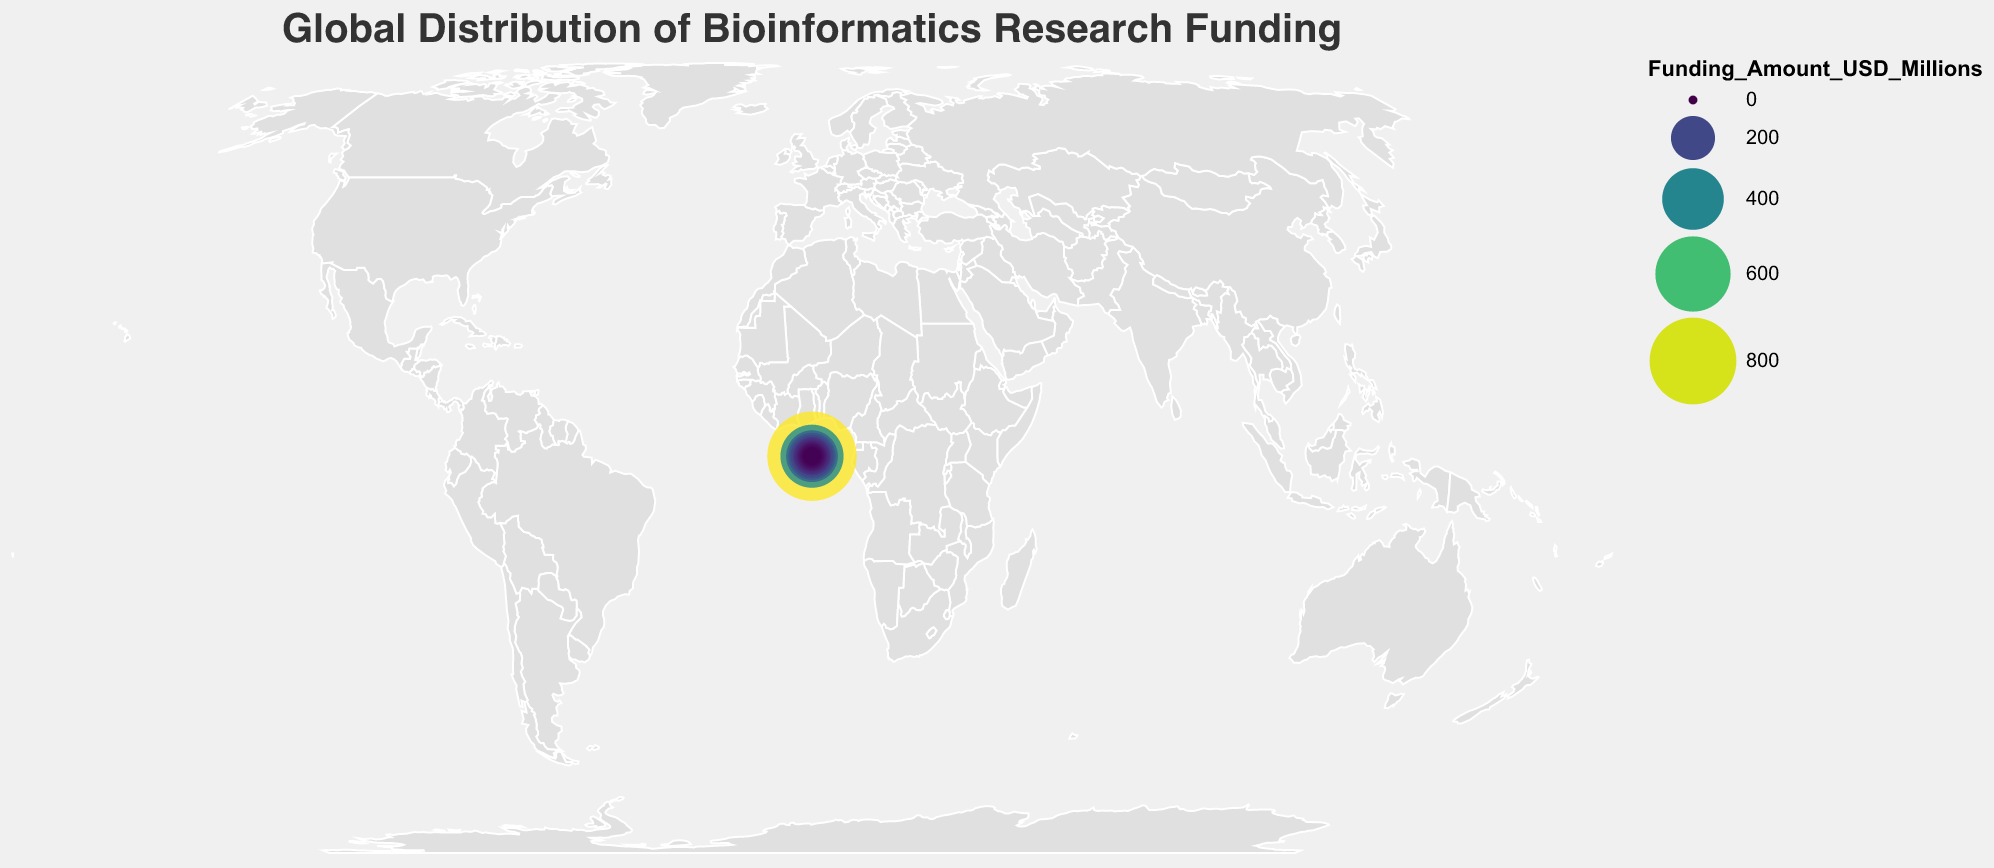What's the title of the plot? The title is prominently displayed at the top of the figure and indicates the topic being visualized.
Answer: Global Distribution of Bioinformatics Research Funding Which country has the highest research funding in bioinformatics? The circles on the plot represent funding amounts by their size and color. The largest and most intensely colored circle corresponds to the country with the highest funding.
Answer: United States What is the research funding amount for Germany? Hovering over or checking the relevant circle on the figure reveals a tooltip with detailed information about each country's funding.
Answer: 230 million USD How does the research funding in China compare to Japan? By observing the sizes and colors of the circles or tooltips, one can compare these two countries directly.
Answer: China has significantly more funding than Japan (420 vs. 190 million USD) What's the total funding amount for the top 3 countries? Sum the funding amounts for the United States, China, and the United Kingdom: 850 + 420 + 280 = 1550 million USD.
Answer: 1550 million USD Which country has the lowest research funding? Identifying the smallest and least intensely colored circle, or observing the presented data, reveals this information.
Answer: Israel What's the difference in funding between the United Kingdom and Canada? Subtract Canada's funding amount from the United Kingdom's amount: 280 million USD - 150 million USD.
Answer: 130 million USD What are the funding amounts for the countries in Europe, and which European country has the highest funding? Look for European countries and note their funding amounts. The countries include the United Kingdom (280), Germany (230), France (130), Switzerland (90), Netherlands (85), Sweden (70), Italy (55), Spain (50), Denmark (35), Belgium (30). The highest amount among these is 280 from the United Kingdom.
Answer: United Kingdom; 280 million USD What is the average funding amount for all listed countries? Sum all the funding amounts and divide by the number of countries: (850 + 420 + 280 + 230 + 190 + 150 + 130 + 110 + 90 + 85 + 70 + 65 + 60 + 55 + 50 + 45 + 40 + 35 + 30 + 25) / 20. This calculates to a total of 3160 million USD divided by 20.
Answer: 158 million USD 